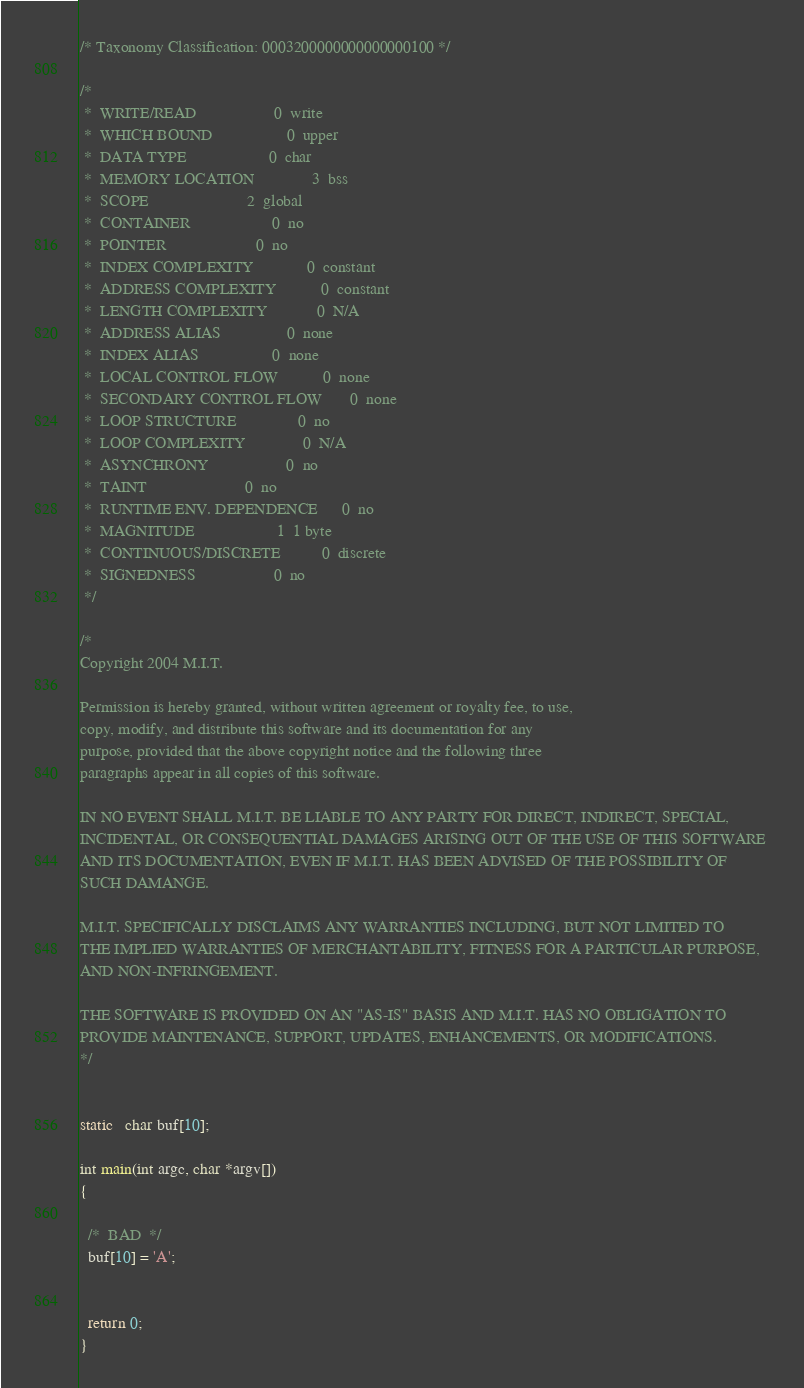Convert code to text. <code><loc_0><loc_0><loc_500><loc_500><_C_>/* Taxonomy Classification: 0003200000000000000100 */

/*
 *  WRITE/READ               	 0	write
 *  WHICH BOUND              	 0	upper
 *  DATA TYPE                	 0	char
 *  MEMORY LOCATION          	 3	bss
 *  SCOPE                    	 2	global
 *  CONTAINER                	 0	no
 *  POINTER                  	 0	no
 *  INDEX COMPLEXITY         	 0	constant
 *  ADDRESS COMPLEXITY       	 0	constant
 *  LENGTH COMPLEXITY        	 0	N/A
 *  ADDRESS ALIAS            	 0	none
 *  INDEX ALIAS              	 0	none
 *  LOCAL CONTROL FLOW       	 0	none
 *  SECONDARY CONTROL FLOW   	 0	none
 *  LOOP STRUCTURE           	 0	no
 *  LOOP COMPLEXITY          	 0	N/A
 *  ASYNCHRONY               	 0	no
 *  TAINT                    	 0	no
 *  RUNTIME ENV. DEPENDENCE  	 0	no
 *  MAGNITUDE                	 1	1 byte
 *  CONTINUOUS/DISCRETE      	 0	discrete
 *  SIGNEDNESS               	 0	no
 */

/*
Copyright 2004 M.I.T.

Permission is hereby granted, without written agreement or royalty fee, to use, 
copy, modify, and distribute this software and its documentation for any 
purpose, provided that the above copyright notice and the following three 
paragraphs appear in all copies of this software.

IN NO EVENT SHALL M.I.T. BE LIABLE TO ANY PARTY FOR DIRECT, INDIRECT, SPECIAL, 
INCIDENTAL, OR CONSEQUENTIAL DAMAGES ARISING OUT OF THE USE OF THIS SOFTWARE 
AND ITS DOCUMENTATION, EVEN IF M.I.T. HAS BEEN ADVISED OF THE POSSIBILITY OF 
SUCH DAMANGE.

M.I.T. SPECIFICALLY DISCLAIMS ANY WARRANTIES INCLUDING, BUT NOT LIMITED TO 
THE IMPLIED WARRANTIES OF MERCHANTABILITY, FITNESS FOR A PARTICULAR PURPOSE, 
AND NON-INFRINGEMENT.

THE SOFTWARE IS PROVIDED ON AN "AS-IS" BASIS AND M.I.T. HAS NO OBLIGATION TO 
PROVIDE MAINTENANCE, SUPPORT, UPDATES, ENHANCEMENTS, OR MODIFICATIONS.
*/


static   char buf[10];

int main(int argc, char *argv[])
{

  /*  BAD  */
  buf[10] = 'A';


  return 0;
}
</code> 